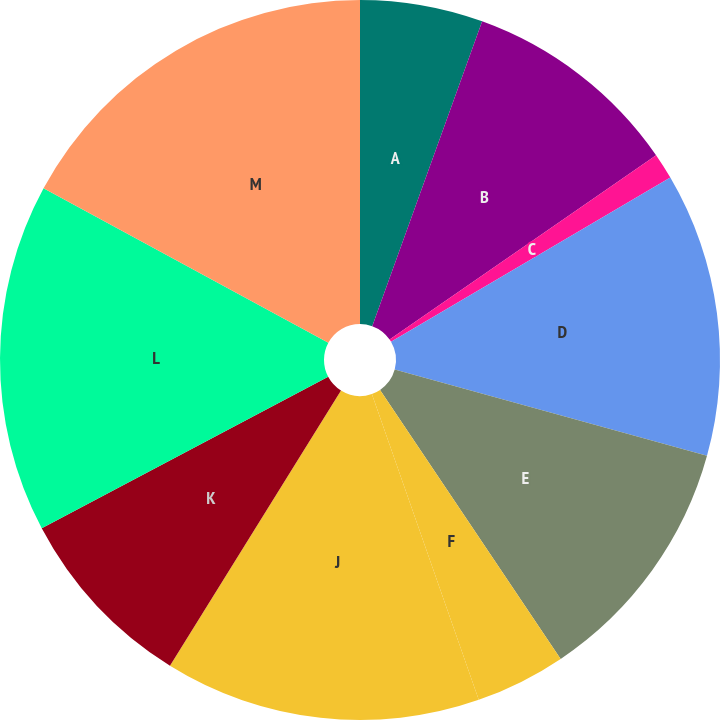<chart> <loc_0><loc_0><loc_500><loc_500><pie_chart><fcel>A<fcel>B<fcel>C<fcel>D<fcel>E<fcel>F<fcel>J<fcel>K<fcel>L<fcel>M<nl><fcel>5.51%<fcel>9.86%<fcel>1.17%<fcel>12.75%<fcel>11.3%<fcel>4.06%<fcel>14.2%<fcel>8.41%<fcel>15.65%<fcel>17.09%<nl></chart> 